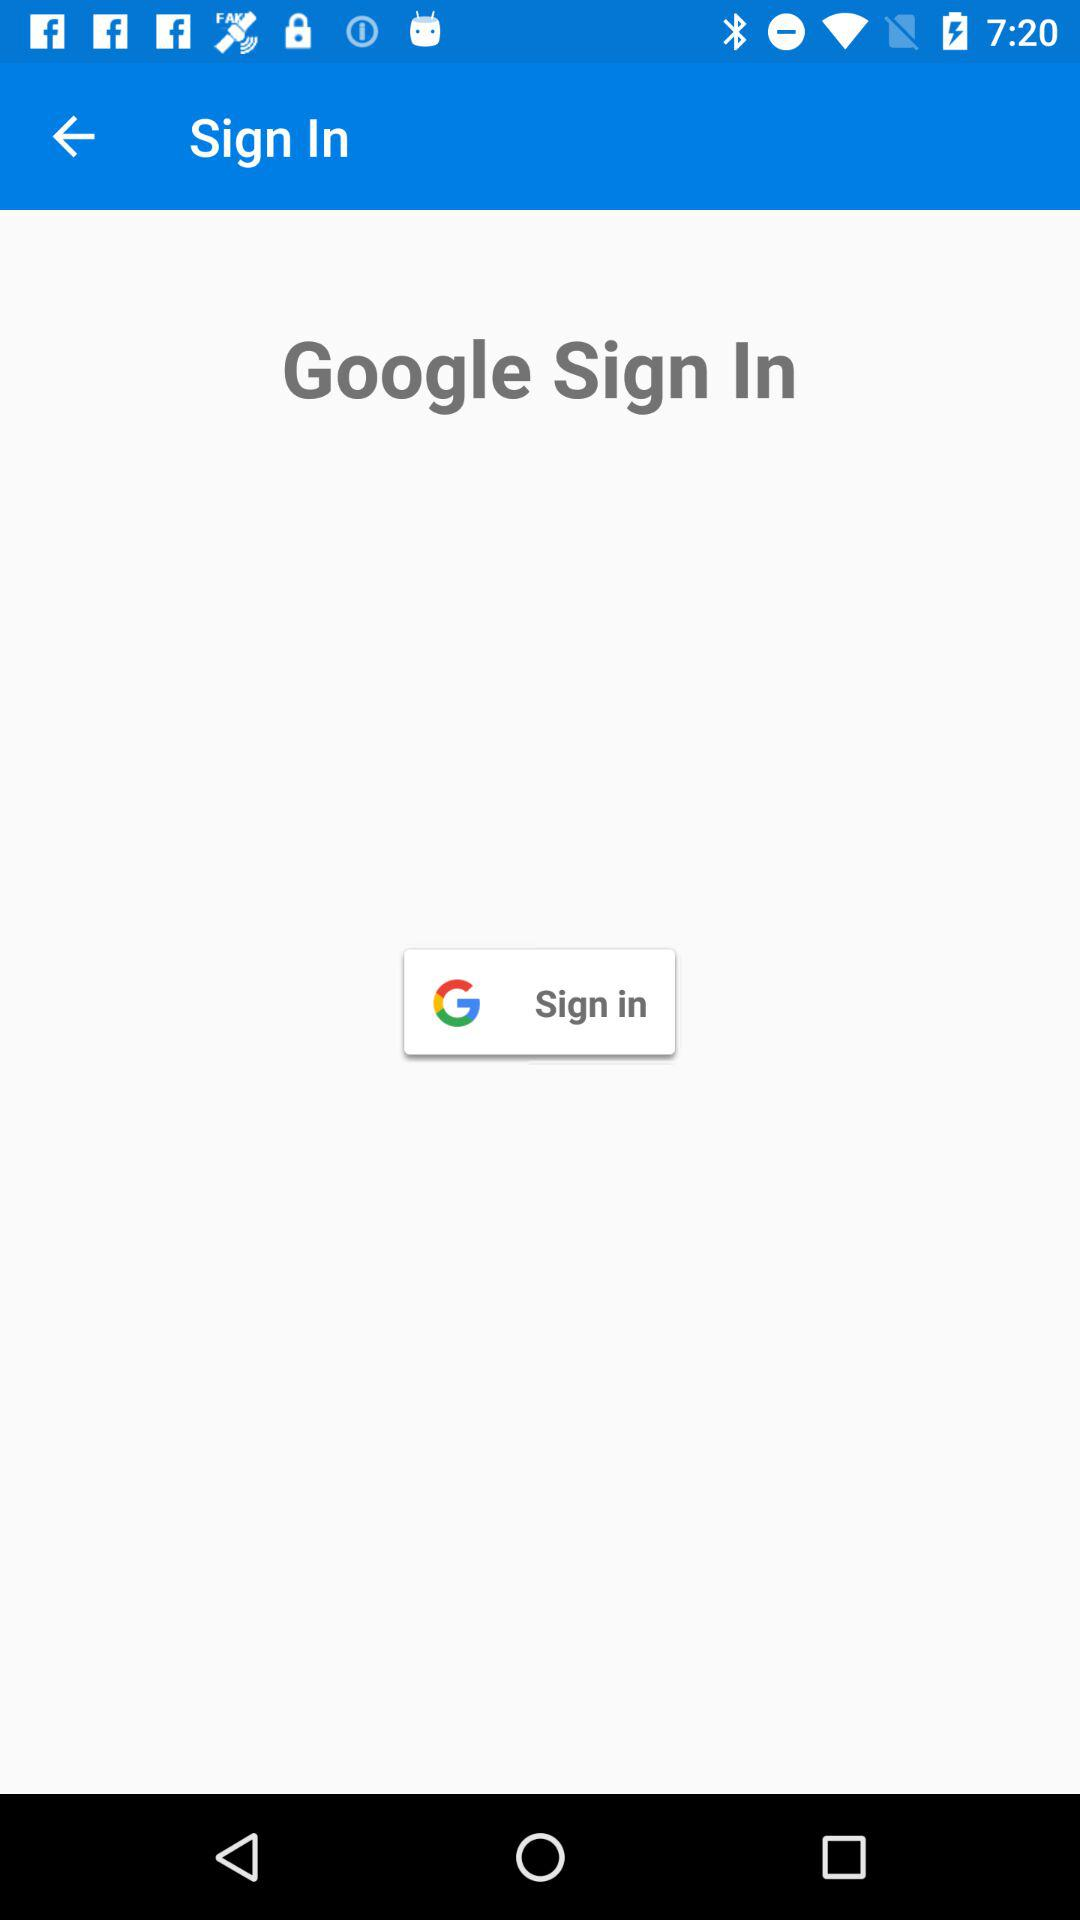What application can be used to sign in to the profile? The application that can be used to sign in is "Google". 